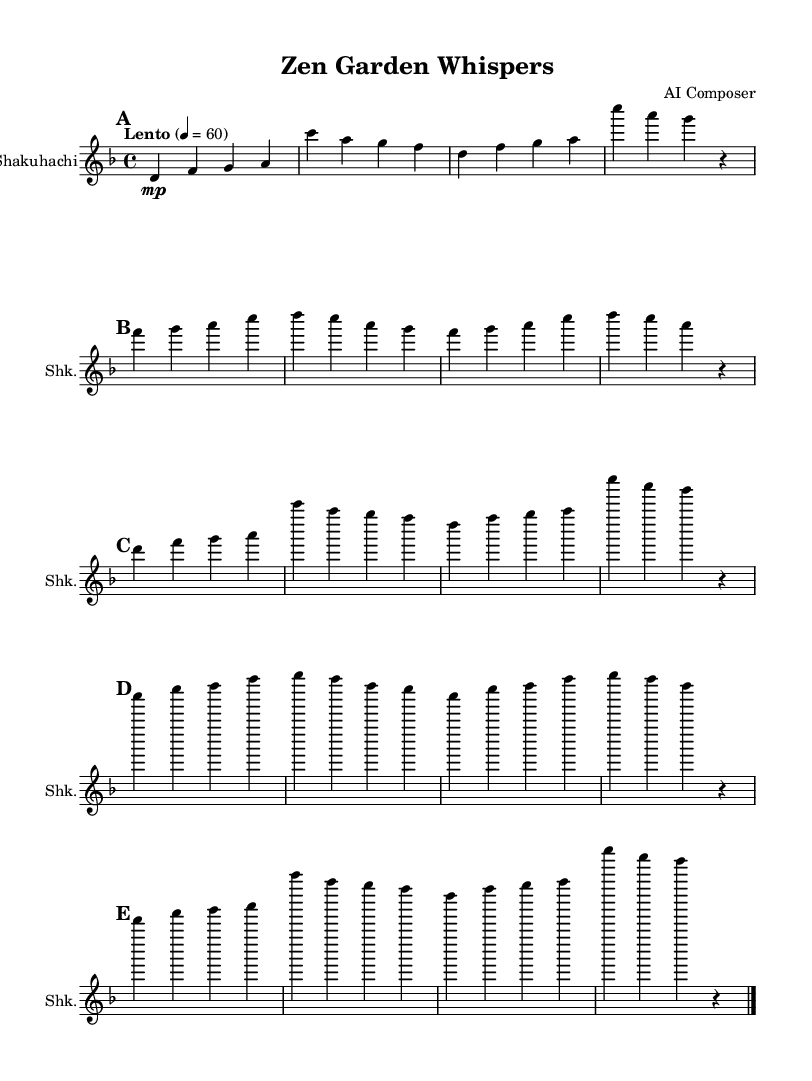What is the key signature of this music? The key signature is D minor, which has one flat (B flat). This can be identified by looking at the key signature indicator at the beginning of the sheet music.
Answer: D minor What is the time signature of this piece? The time signature is 4/4, meaning there are four beats in a bar and the quarter note gets one beat. This is located at the beginning of the score near the key signature.
Answer: 4/4 What is the tempo marking of this music? The tempo marking indicates "Lento" at a speed of 60 beats per minute. This information can be found near the beginning of the sheet music where tempo is usually indicated.
Answer: Lento How many sections are in this composition? There are five sections identified as A, B, A', C, and A''. This can be seen in the corresponding labels for each section throughout the sheet music.
Answer: Five Which instrument is this composition written for? The composition is specifically written for the shakuhachi, as indicated by the instrument name at the beginning of the staff.
Answer: Shakuhachi What is the rhythmic value of the first note? The first note is a D quarter note, meaning it lasts for one beat. The note's placement and the context of the time signature indicates its duration.
Answer: D quarter note What musical qualities does this type of music promote? This music promotes inner peace and balance, characteristic of tranquil Japanese shakuhachi music often used in meditation. The overall calmness and tempo contribute to this effect.
Answer: Inner peace and balance 